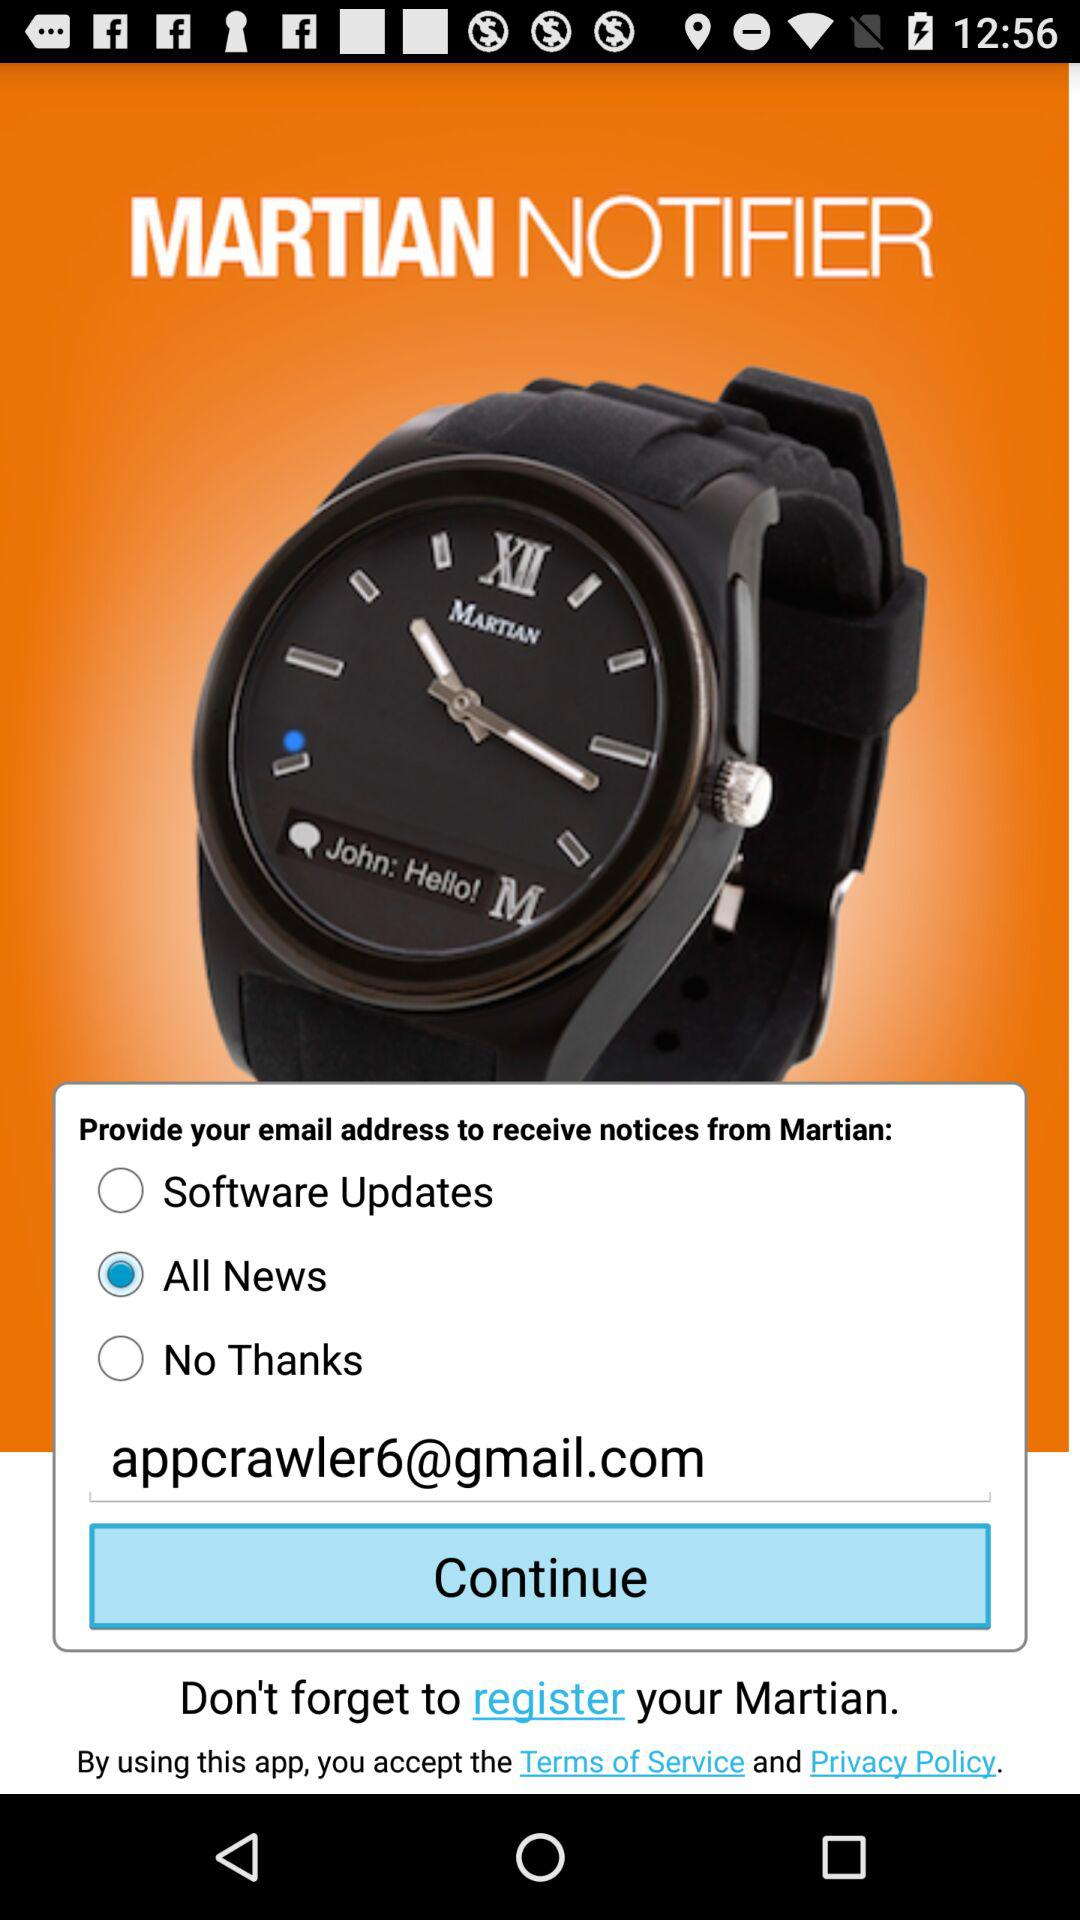Is "Software Updates" selected or not? "Software Updates" is not selected. 